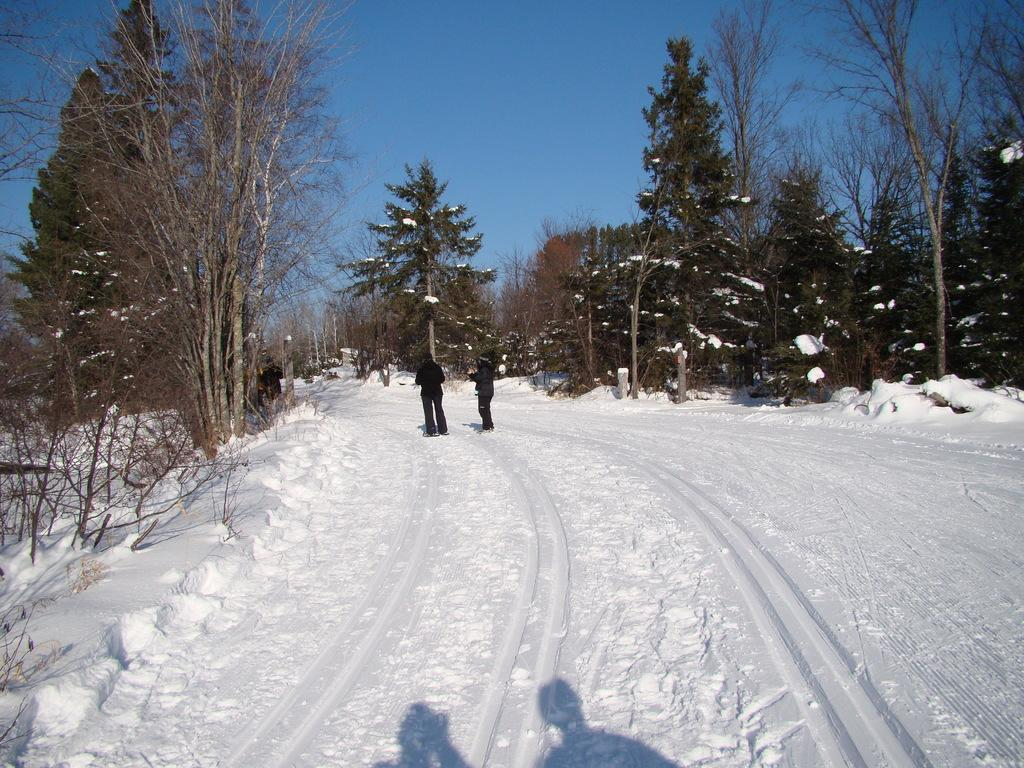What is the surface on which the people are standing in the image? The people are standing on the snow in the image. What color are the dresses worn by the people? The people are wearing black-colored dresses. What type of vegetation can be seen in the image? There are many trees visible in the image. What is visible in the background of the image? The sky is visible in the background of the image. Where is the seed that fell from the tree in the image? There is no seed falling from a tree in the image; it only shows people standing on the snow and trees in the background. What type of furniture can be seen in the bedroom in the image? There is no bedroom present in the image; it features people standing on the snow and trees in the background. 